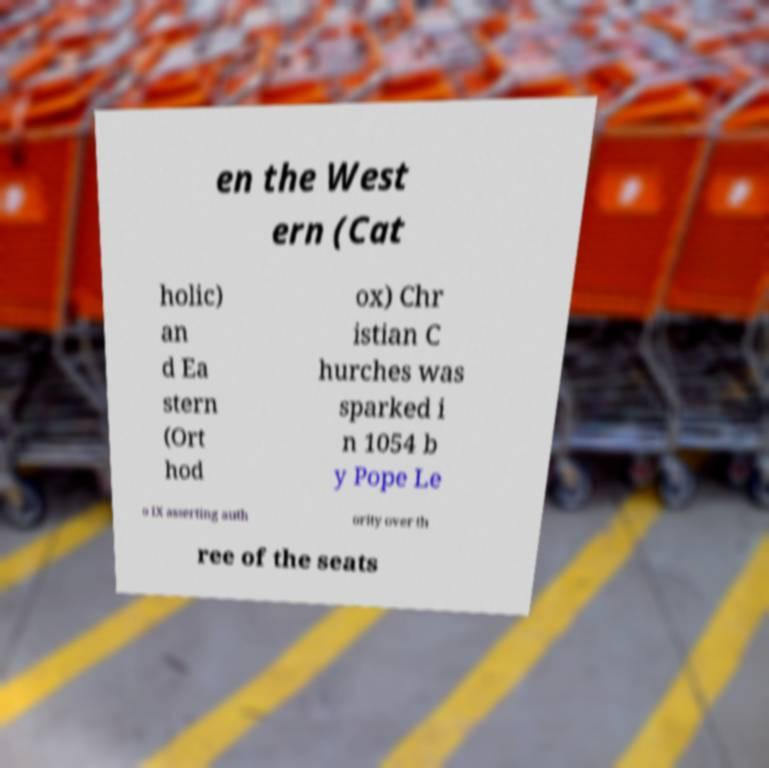Could you assist in decoding the text presented in this image and type it out clearly? en the West ern (Cat holic) an d Ea stern (Ort hod ox) Chr istian C hurches was sparked i n 1054 b y Pope Le o IX asserting auth ority over th ree of the seats 